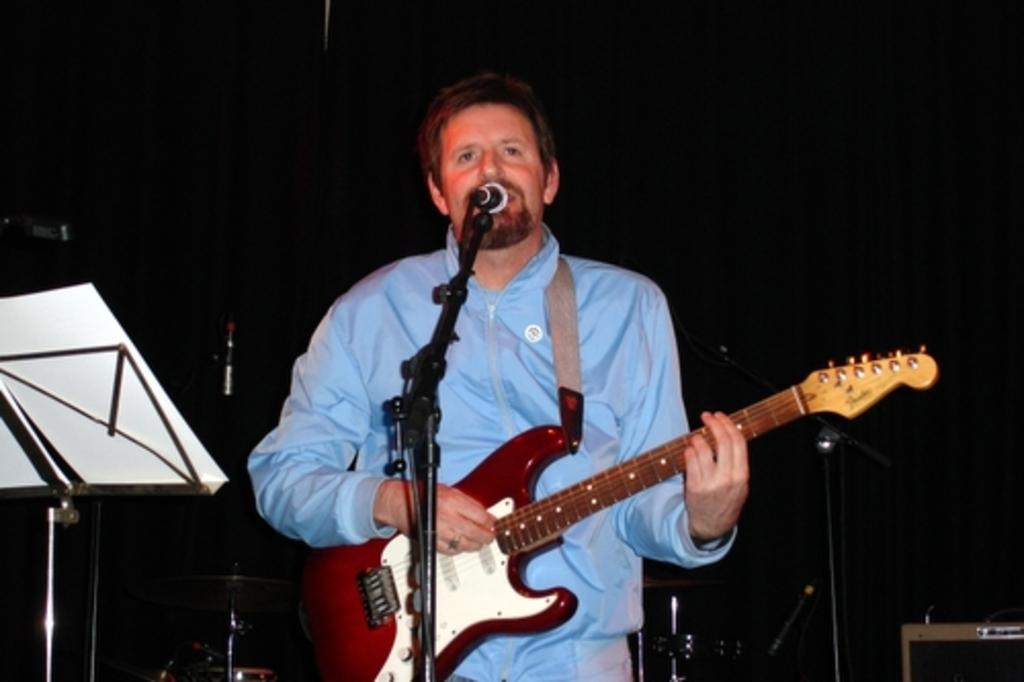Who is the main subject in the image? There is a man in the image. What is the man holding in the image? The man is holding a guitar. What is the man standing in front of in the image? The man is standing in front of a microphone. What object can be seen beside the man in the image? There is a stand beside the man. What type of metal is the guitar made of in the image? The image does not provide information about the material the guitar is made of, so it cannot be determined from the image. 